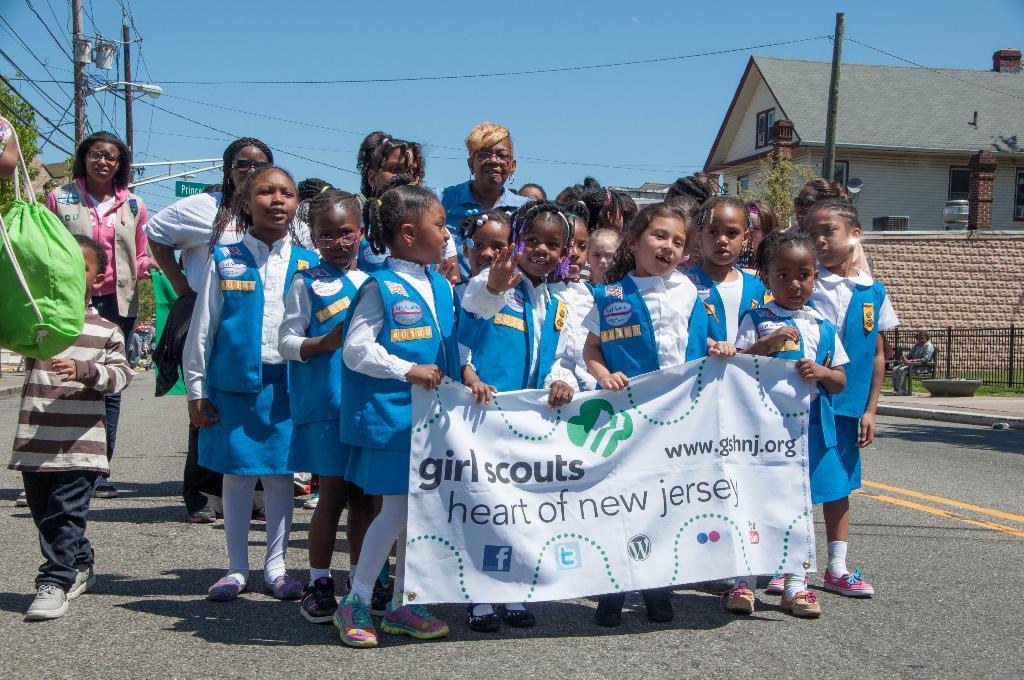In one or two sentences, can you explain what this image depicts? In this image I can see a group of kids holding something with some text written on it. In the background, I can see a house and the sky. 